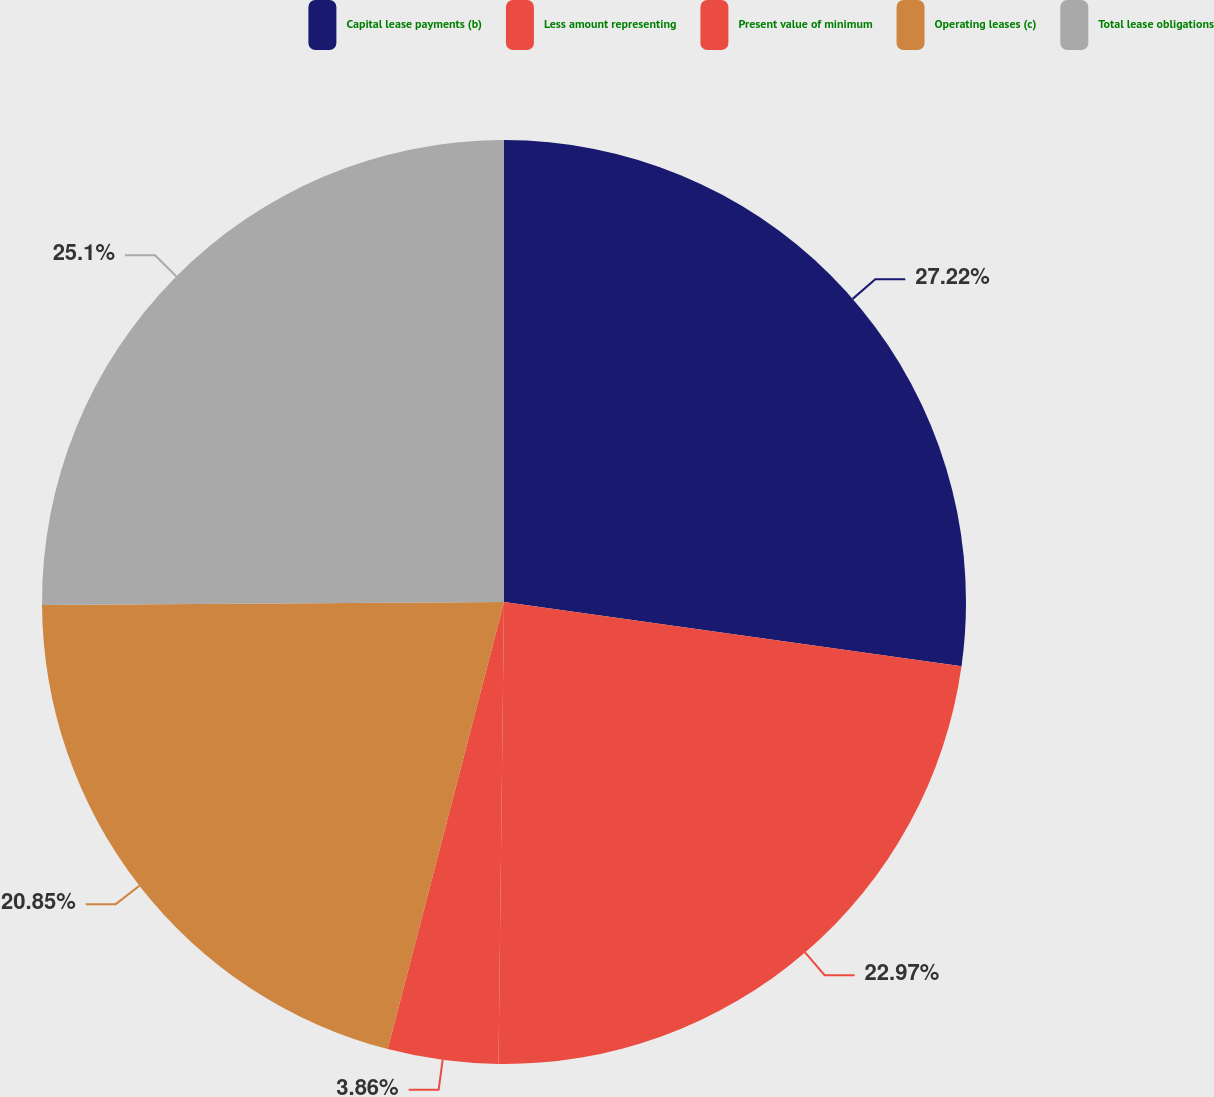Convert chart to OTSL. <chart><loc_0><loc_0><loc_500><loc_500><pie_chart><fcel>Capital lease payments (b)<fcel>Less amount representing<fcel>Present value of minimum<fcel>Operating leases (c)<fcel>Total lease obligations<nl><fcel>27.22%<fcel>22.97%<fcel>3.86%<fcel>20.85%<fcel>25.1%<nl></chart> 